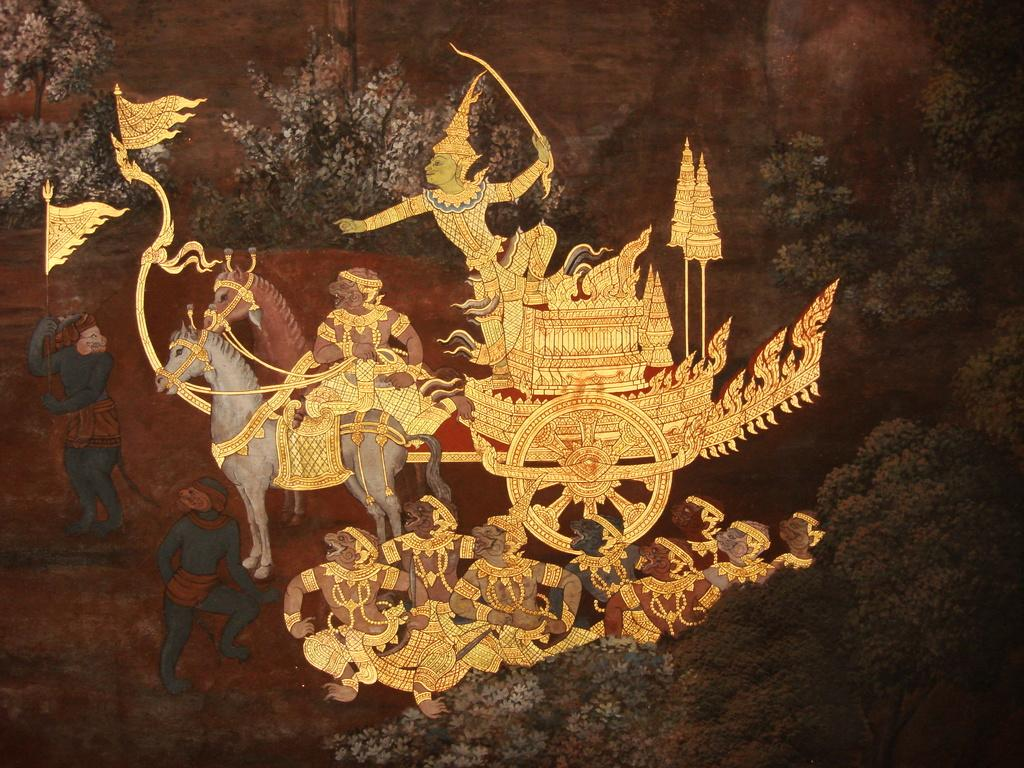What is the main subject of the art piece in the image? The main subject of the art piece in the image is a horse cart. Are there any other elements in the art piece besides the horse cart? Yes, there are people and trees in the art piece. What degree does the artist have in yarn manipulation? The image does not provide information about the artist's degree or any use of yarn in the art piece. 